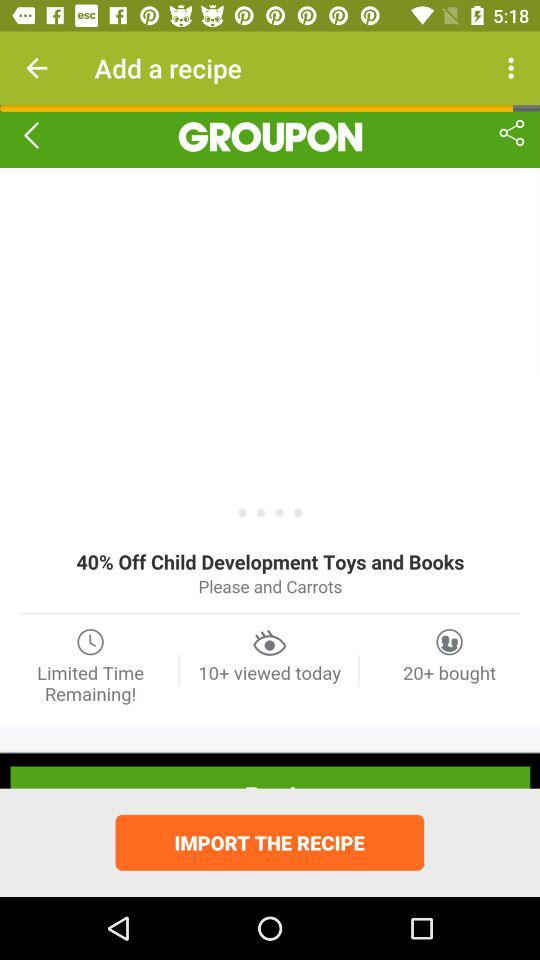What is the application name? The application name is "GROUPON". 